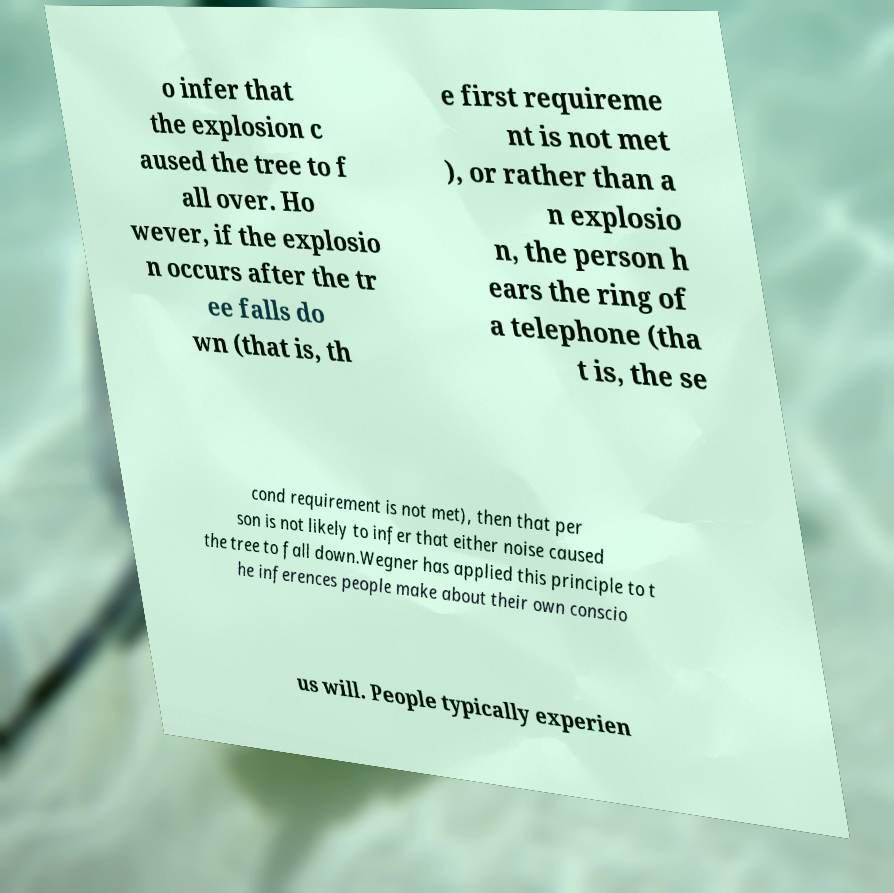I need the written content from this picture converted into text. Can you do that? o infer that the explosion c aused the tree to f all over. Ho wever, if the explosio n occurs after the tr ee falls do wn (that is, th e first requireme nt is not met ), or rather than a n explosio n, the person h ears the ring of a telephone (tha t is, the se cond requirement is not met), then that per son is not likely to infer that either noise caused the tree to fall down.Wegner has applied this principle to t he inferences people make about their own conscio us will. People typically experien 